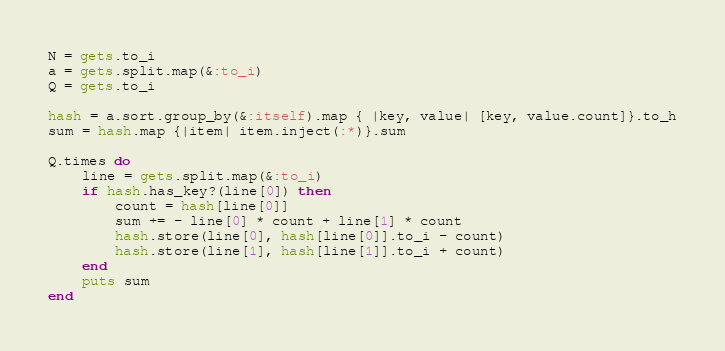Convert code to text. <code><loc_0><loc_0><loc_500><loc_500><_Ruby_>N = gets.to_i
a = gets.split.map(&:to_i)
Q = gets.to_i

hash = a.sort.group_by(&:itself).map { |key, value| [key, value.count]}.to_h
sum = hash.map {|item| item.inject(:*)}.sum

Q.times do
    line = gets.split.map(&:to_i)
    if hash.has_key?(line[0]) then
        count = hash[line[0]]
        sum += - line[0] * count + line[1] * count
        hash.store(line[0], hash[line[0]].to_i - count)
        hash.store(line[1], hash[line[1]].to_i + count)
    end
    puts sum
end
</code> 